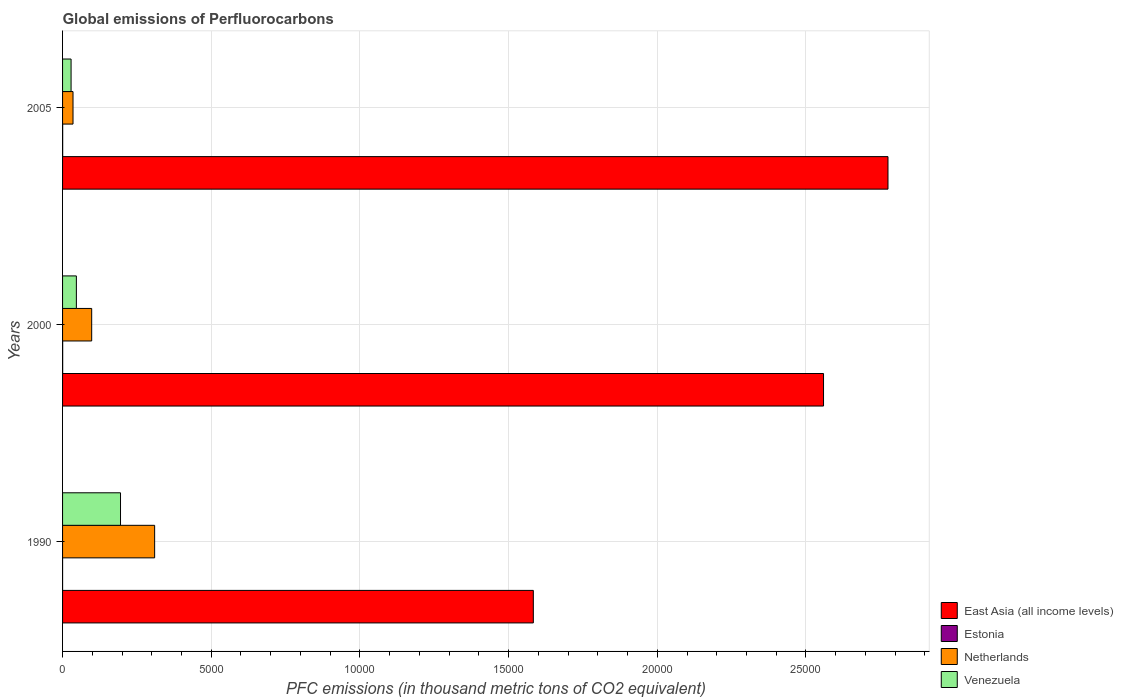How many different coloured bars are there?
Offer a very short reply. 4. How many bars are there on the 3rd tick from the bottom?
Offer a very short reply. 4. What is the label of the 2nd group of bars from the top?
Your response must be concise. 2000. In how many cases, is the number of bars for a given year not equal to the number of legend labels?
Your response must be concise. 0. What is the global emissions of Perfluorocarbons in Estonia in 2000?
Your answer should be compact. 3.5. Across all years, what is the maximum global emissions of Perfluorocarbons in Estonia?
Your answer should be compact. 3.5. Across all years, what is the minimum global emissions of Perfluorocarbons in East Asia (all income levels)?
Offer a terse response. 1.58e+04. In which year was the global emissions of Perfluorocarbons in East Asia (all income levels) maximum?
Provide a succinct answer. 2005. What is the total global emissions of Perfluorocarbons in Venezuela in the graph?
Provide a short and direct response. 2699.4. What is the difference between the global emissions of Perfluorocarbons in Venezuela in 2000 and that in 2005?
Offer a very short reply. 178.5. What is the difference between the global emissions of Perfluorocarbons in Venezuela in 1990 and the global emissions of Perfluorocarbons in East Asia (all income levels) in 2005?
Your response must be concise. -2.58e+04. What is the average global emissions of Perfluorocarbons in East Asia (all income levels) per year?
Give a very brief answer. 2.31e+04. In the year 1990, what is the difference between the global emissions of Perfluorocarbons in East Asia (all income levels) and global emissions of Perfluorocarbons in Venezuela?
Your response must be concise. 1.39e+04. What is the ratio of the global emissions of Perfluorocarbons in Estonia in 2000 to that in 2005?
Offer a terse response. 1.03. What is the difference between the highest and the second highest global emissions of Perfluorocarbons in Netherlands?
Your answer should be very brief. 2116.7. What is the difference between the highest and the lowest global emissions of Perfluorocarbons in Netherlands?
Your answer should be compact. 2744.8. Is it the case that in every year, the sum of the global emissions of Perfluorocarbons in Netherlands and global emissions of Perfluorocarbons in Estonia is greater than the sum of global emissions of Perfluorocarbons in East Asia (all income levels) and global emissions of Perfluorocarbons in Venezuela?
Offer a very short reply. No. What does the 1st bar from the top in 2000 represents?
Provide a short and direct response. Venezuela. What does the 1st bar from the bottom in 1990 represents?
Provide a succinct answer. East Asia (all income levels). Is it the case that in every year, the sum of the global emissions of Perfluorocarbons in Netherlands and global emissions of Perfluorocarbons in East Asia (all income levels) is greater than the global emissions of Perfluorocarbons in Venezuela?
Ensure brevity in your answer.  Yes. How many years are there in the graph?
Your answer should be compact. 3. What is the difference between two consecutive major ticks on the X-axis?
Your answer should be compact. 5000. Are the values on the major ticks of X-axis written in scientific E-notation?
Your response must be concise. No. Does the graph contain any zero values?
Your response must be concise. No. Does the graph contain grids?
Offer a very short reply. Yes. Where does the legend appear in the graph?
Your response must be concise. Bottom right. How many legend labels are there?
Provide a succinct answer. 4. What is the title of the graph?
Keep it short and to the point. Global emissions of Perfluorocarbons. Does "Low & middle income" appear as one of the legend labels in the graph?
Your answer should be very brief. No. What is the label or title of the X-axis?
Your answer should be compact. PFC emissions (in thousand metric tons of CO2 equivalent). What is the label or title of the Y-axis?
Offer a terse response. Years. What is the PFC emissions (in thousand metric tons of CO2 equivalent) in East Asia (all income levels) in 1990?
Make the answer very short. 1.58e+04. What is the PFC emissions (in thousand metric tons of CO2 equivalent) of Estonia in 1990?
Offer a terse response. 0.5. What is the PFC emissions (in thousand metric tons of CO2 equivalent) in Netherlands in 1990?
Provide a short and direct response. 3096.2. What is the PFC emissions (in thousand metric tons of CO2 equivalent) in Venezuela in 1990?
Your answer should be very brief. 1948.7. What is the PFC emissions (in thousand metric tons of CO2 equivalent) of East Asia (all income levels) in 2000?
Provide a succinct answer. 2.56e+04. What is the PFC emissions (in thousand metric tons of CO2 equivalent) in Netherlands in 2000?
Offer a very short reply. 979.5. What is the PFC emissions (in thousand metric tons of CO2 equivalent) in Venezuela in 2000?
Make the answer very short. 464.6. What is the PFC emissions (in thousand metric tons of CO2 equivalent) of East Asia (all income levels) in 2005?
Give a very brief answer. 2.78e+04. What is the PFC emissions (in thousand metric tons of CO2 equivalent) of Estonia in 2005?
Keep it short and to the point. 3.4. What is the PFC emissions (in thousand metric tons of CO2 equivalent) in Netherlands in 2005?
Offer a terse response. 351.4. What is the PFC emissions (in thousand metric tons of CO2 equivalent) of Venezuela in 2005?
Make the answer very short. 286.1. Across all years, what is the maximum PFC emissions (in thousand metric tons of CO2 equivalent) in East Asia (all income levels)?
Your answer should be very brief. 2.78e+04. Across all years, what is the maximum PFC emissions (in thousand metric tons of CO2 equivalent) of Netherlands?
Offer a terse response. 3096.2. Across all years, what is the maximum PFC emissions (in thousand metric tons of CO2 equivalent) of Venezuela?
Ensure brevity in your answer.  1948.7. Across all years, what is the minimum PFC emissions (in thousand metric tons of CO2 equivalent) in East Asia (all income levels)?
Provide a succinct answer. 1.58e+04. Across all years, what is the minimum PFC emissions (in thousand metric tons of CO2 equivalent) in Netherlands?
Give a very brief answer. 351.4. Across all years, what is the minimum PFC emissions (in thousand metric tons of CO2 equivalent) in Venezuela?
Provide a succinct answer. 286.1. What is the total PFC emissions (in thousand metric tons of CO2 equivalent) in East Asia (all income levels) in the graph?
Ensure brevity in your answer.  6.92e+04. What is the total PFC emissions (in thousand metric tons of CO2 equivalent) in Netherlands in the graph?
Give a very brief answer. 4427.1. What is the total PFC emissions (in thousand metric tons of CO2 equivalent) in Venezuela in the graph?
Your answer should be very brief. 2699.4. What is the difference between the PFC emissions (in thousand metric tons of CO2 equivalent) of East Asia (all income levels) in 1990 and that in 2000?
Offer a very short reply. -9759.3. What is the difference between the PFC emissions (in thousand metric tons of CO2 equivalent) in Netherlands in 1990 and that in 2000?
Offer a terse response. 2116.7. What is the difference between the PFC emissions (in thousand metric tons of CO2 equivalent) of Venezuela in 1990 and that in 2000?
Provide a succinct answer. 1484.1. What is the difference between the PFC emissions (in thousand metric tons of CO2 equivalent) of East Asia (all income levels) in 1990 and that in 2005?
Make the answer very short. -1.19e+04. What is the difference between the PFC emissions (in thousand metric tons of CO2 equivalent) of Estonia in 1990 and that in 2005?
Provide a succinct answer. -2.9. What is the difference between the PFC emissions (in thousand metric tons of CO2 equivalent) of Netherlands in 1990 and that in 2005?
Provide a short and direct response. 2744.8. What is the difference between the PFC emissions (in thousand metric tons of CO2 equivalent) in Venezuela in 1990 and that in 2005?
Give a very brief answer. 1662.6. What is the difference between the PFC emissions (in thousand metric tons of CO2 equivalent) of East Asia (all income levels) in 2000 and that in 2005?
Provide a short and direct response. -2167.69. What is the difference between the PFC emissions (in thousand metric tons of CO2 equivalent) of Estonia in 2000 and that in 2005?
Provide a short and direct response. 0.1. What is the difference between the PFC emissions (in thousand metric tons of CO2 equivalent) in Netherlands in 2000 and that in 2005?
Offer a very short reply. 628.1. What is the difference between the PFC emissions (in thousand metric tons of CO2 equivalent) of Venezuela in 2000 and that in 2005?
Ensure brevity in your answer.  178.5. What is the difference between the PFC emissions (in thousand metric tons of CO2 equivalent) in East Asia (all income levels) in 1990 and the PFC emissions (in thousand metric tons of CO2 equivalent) in Estonia in 2000?
Offer a very short reply. 1.58e+04. What is the difference between the PFC emissions (in thousand metric tons of CO2 equivalent) of East Asia (all income levels) in 1990 and the PFC emissions (in thousand metric tons of CO2 equivalent) of Netherlands in 2000?
Make the answer very short. 1.49e+04. What is the difference between the PFC emissions (in thousand metric tons of CO2 equivalent) of East Asia (all income levels) in 1990 and the PFC emissions (in thousand metric tons of CO2 equivalent) of Venezuela in 2000?
Offer a terse response. 1.54e+04. What is the difference between the PFC emissions (in thousand metric tons of CO2 equivalent) of Estonia in 1990 and the PFC emissions (in thousand metric tons of CO2 equivalent) of Netherlands in 2000?
Make the answer very short. -979. What is the difference between the PFC emissions (in thousand metric tons of CO2 equivalent) in Estonia in 1990 and the PFC emissions (in thousand metric tons of CO2 equivalent) in Venezuela in 2000?
Keep it short and to the point. -464.1. What is the difference between the PFC emissions (in thousand metric tons of CO2 equivalent) in Netherlands in 1990 and the PFC emissions (in thousand metric tons of CO2 equivalent) in Venezuela in 2000?
Offer a terse response. 2631.6. What is the difference between the PFC emissions (in thousand metric tons of CO2 equivalent) in East Asia (all income levels) in 1990 and the PFC emissions (in thousand metric tons of CO2 equivalent) in Estonia in 2005?
Your answer should be very brief. 1.58e+04. What is the difference between the PFC emissions (in thousand metric tons of CO2 equivalent) of East Asia (all income levels) in 1990 and the PFC emissions (in thousand metric tons of CO2 equivalent) of Netherlands in 2005?
Your answer should be compact. 1.55e+04. What is the difference between the PFC emissions (in thousand metric tons of CO2 equivalent) of East Asia (all income levels) in 1990 and the PFC emissions (in thousand metric tons of CO2 equivalent) of Venezuela in 2005?
Give a very brief answer. 1.55e+04. What is the difference between the PFC emissions (in thousand metric tons of CO2 equivalent) in Estonia in 1990 and the PFC emissions (in thousand metric tons of CO2 equivalent) in Netherlands in 2005?
Give a very brief answer. -350.9. What is the difference between the PFC emissions (in thousand metric tons of CO2 equivalent) of Estonia in 1990 and the PFC emissions (in thousand metric tons of CO2 equivalent) of Venezuela in 2005?
Offer a terse response. -285.6. What is the difference between the PFC emissions (in thousand metric tons of CO2 equivalent) in Netherlands in 1990 and the PFC emissions (in thousand metric tons of CO2 equivalent) in Venezuela in 2005?
Your response must be concise. 2810.1. What is the difference between the PFC emissions (in thousand metric tons of CO2 equivalent) in East Asia (all income levels) in 2000 and the PFC emissions (in thousand metric tons of CO2 equivalent) in Estonia in 2005?
Offer a terse response. 2.56e+04. What is the difference between the PFC emissions (in thousand metric tons of CO2 equivalent) of East Asia (all income levels) in 2000 and the PFC emissions (in thousand metric tons of CO2 equivalent) of Netherlands in 2005?
Provide a short and direct response. 2.52e+04. What is the difference between the PFC emissions (in thousand metric tons of CO2 equivalent) of East Asia (all income levels) in 2000 and the PFC emissions (in thousand metric tons of CO2 equivalent) of Venezuela in 2005?
Offer a very short reply. 2.53e+04. What is the difference between the PFC emissions (in thousand metric tons of CO2 equivalent) in Estonia in 2000 and the PFC emissions (in thousand metric tons of CO2 equivalent) in Netherlands in 2005?
Give a very brief answer. -347.9. What is the difference between the PFC emissions (in thousand metric tons of CO2 equivalent) in Estonia in 2000 and the PFC emissions (in thousand metric tons of CO2 equivalent) in Venezuela in 2005?
Provide a short and direct response. -282.6. What is the difference between the PFC emissions (in thousand metric tons of CO2 equivalent) in Netherlands in 2000 and the PFC emissions (in thousand metric tons of CO2 equivalent) in Venezuela in 2005?
Make the answer very short. 693.4. What is the average PFC emissions (in thousand metric tons of CO2 equivalent) in East Asia (all income levels) per year?
Ensure brevity in your answer.  2.31e+04. What is the average PFC emissions (in thousand metric tons of CO2 equivalent) of Estonia per year?
Provide a short and direct response. 2.47. What is the average PFC emissions (in thousand metric tons of CO2 equivalent) in Netherlands per year?
Ensure brevity in your answer.  1475.7. What is the average PFC emissions (in thousand metric tons of CO2 equivalent) of Venezuela per year?
Offer a terse response. 899.8. In the year 1990, what is the difference between the PFC emissions (in thousand metric tons of CO2 equivalent) of East Asia (all income levels) and PFC emissions (in thousand metric tons of CO2 equivalent) of Estonia?
Offer a very short reply. 1.58e+04. In the year 1990, what is the difference between the PFC emissions (in thousand metric tons of CO2 equivalent) in East Asia (all income levels) and PFC emissions (in thousand metric tons of CO2 equivalent) in Netherlands?
Ensure brevity in your answer.  1.27e+04. In the year 1990, what is the difference between the PFC emissions (in thousand metric tons of CO2 equivalent) in East Asia (all income levels) and PFC emissions (in thousand metric tons of CO2 equivalent) in Venezuela?
Offer a terse response. 1.39e+04. In the year 1990, what is the difference between the PFC emissions (in thousand metric tons of CO2 equivalent) in Estonia and PFC emissions (in thousand metric tons of CO2 equivalent) in Netherlands?
Make the answer very short. -3095.7. In the year 1990, what is the difference between the PFC emissions (in thousand metric tons of CO2 equivalent) in Estonia and PFC emissions (in thousand metric tons of CO2 equivalent) in Venezuela?
Offer a terse response. -1948.2. In the year 1990, what is the difference between the PFC emissions (in thousand metric tons of CO2 equivalent) of Netherlands and PFC emissions (in thousand metric tons of CO2 equivalent) of Venezuela?
Offer a terse response. 1147.5. In the year 2000, what is the difference between the PFC emissions (in thousand metric tons of CO2 equivalent) in East Asia (all income levels) and PFC emissions (in thousand metric tons of CO2 equivalent) in Estonia?
Your response must be concise. 2.56e+04. In the year 2000, what is the difference between the PFC emissions (in thousand metric tons of CO2 equivalent) in East Asia (all income levels) and PFC emissions (in thousand metric tons of CO2 equivalent) in Netherlands?
Provide a succinct answer. 2.46e+04. In the year 2000, what is the difference between the PFC emissions (in thousand metric tons of CO2 equivalent) of East Asia (all income levels) and PFC emissions (in thousand metric tons of CO2 equivalent) of Venezuela?
Provide a succinct answer. 2.51e+04. In the year 2000, what is the difference between the PFC emissions (in thousand metric tons of CO2 equivalent) of Estonia and PFC emissions (in thousand metric tons of CO2 equivalent) of Netherlands?
Offer a very short reply. -976. In the year 2000, what is the difference between the PFC emissions (in thousand metric tons of CO2 equivalent) in Estonia and PFC emissions (in thousand metric tons of CO2 equivalent) in Venezuela?
Give a very brief answer. -461.1. In the year 2000, what is the difference between the PFC emissions (in thousand metric tons of CO2 equivalent) in Netherlands and PFC emissions (in thousand metric tons of CO2 equivalent) in Venezuela?
Offer a very short reply. 514.9. In the year 2005, what is the difference between the PFC emissions (in thousand metric tons of CO2 equivalent) in East Asia (all income levels) and PFC emissions (in thousand metric tons of CO2 equivalent) in Estonia?
Make the answer very short. 2.78e+04. In the year 2005, what is the difference between the PFC emissions (in thousand metric tons of CO2 equivalent) of East Asia (all income levels) and PFC emissions (in thousand metric tons of CO2 equivalent) of Netherlands?
Your response must be concise. 2.74e+04. In the year 2005, what is the difference between the PFC emissions (in thousand metric tons of CO2 equivalent) in East Asia (all income levels) and PFC emissions (in thousand metric tons of CO2 equivalent) in Venezuela?
Ensure brevity in your answer.  2.75e+04. In the year 2005, what is the difference between the PFC emissions (in thousand metric tons of CO2 equivalent) in Estonia and PFC emissions (in thousand metric tons of CO2 equivalent) in Netherlands?
Offer a terse response. -348. In the year 2005, what is the difference between the PFC emissions (in thousand metric tons of CO2 equivalent) in Estonia and PFC emissions (in thousand metric tons of CO2 equivalent) in Venezuela?
Your answer should be very brief. -282.7. In the year 2005, what is the difference between the PFC emissions (in thousand metric tons of CO2 equivalent) in Netherlands and PFC emissions (in thousand metric tons of CO2 equivalent) in Venezuela?
Give a very brief answer. 65.3. What is the ratio of the PFC emissions (in thousand metric tons of CO2 equivalent) in East Asia (all income levels) in 1990 to that in 2000?
Give a very brief answer. 0.62. What is the ratio of the PFC emissions (in thousand metric tons of CO2 equivalent) of Estonia in 1990 to that in 2000?
Provide a succinct answer. 0.14. What is the ratio of the PFC emissions (in thousand metric tons of CO2 equivalent) in Netherlands in 1990 to that in 2000?
Give a very brief answer. 3.16. What is the ratio of the PFC emissions (in thousand metric tons of CO2 equivalent) in Venezuela in 1990 to that in 2000?
Provide a short and direct response. 4.19. What is the ratio of the PFC emissions (in thousand metric tons of CO2 equivalent) of East Asia (all income levels) in 1990 to that in 2005?
Offer a very short reply. 0.57. What is the ratio of the PFC emissions (in thousand metric tons of CO2 equivalent) of Estonia in 1990 to that in 2005?
Keep it short and to the point. 0.15. What is the ratio of the PFC emissions (in thousand metric tons of CO2 equivalent) of Netherlands in 1990 to that in 2005?
Keep it short and to the point. 8.81. What is the ratio of the PFC emissions (in thousand metric tons of CO2 equivalent) of Venezuela in 1990 to that in 2005?
Provide a short and direct response. 6.81. What is the ratio of the PFC emissions (in thousand metric tons of CO2 equivalent) in East Asia (all income levels) in 2000 to that in 2005?
Your answer should be compact. 0.92. What is the ratio of the PFC emissions (in thousand metric tons of CO2 equivalent) in Estonia in 2000 to that in 2005?
Offer a very short reply. 1.03. What is the ratio of the PFC emissions (in thousand metric tons of CO2 equivalent) in Netherlands in 2000 to that in 2005?
Keep it short and to the point. 2.79. What is the ratio of the PFC emissions (in thousand metric tons of CO2 equivalent) in Venezuela in 2000 to that in 2005?
Your response must be concise. 1.62. What is the difference between the highest and the second highest PFC emissions (in thousand metric tons of CO2 equivalent) in East Asia (all income levels)?
Provide a short and direct response. 2167.69. What is the difference between the highest and the second highest PFC emissions (in thousand metric tons of CO2 equivalent) of Netherlands?
Provide a succinct answer. 2116.7. What is the difference between the highest and the second highest PFC emissions (in thousand metric tons of CO2 equivalent) in Venezuela?
Provide a succinct answer. 1484.1. What is the difference between the highest and the lowest PFC emissions (in thousand metric tons of CO2 equivalent) of East Asia (all income levels)?
Your answer should be compact. 1.19e+04. What is the difference between the highest and the lowest PFC emissions (in thousand metric tons of CO2 equivalent) of Netherlands?
Make the answer very short. 2744.8. What is the difference between the highest and the lowest PFC emissions (in thousand metric tons of CO2 equivalent) in Venezuela?
Make the answer very short. 1662.6. 